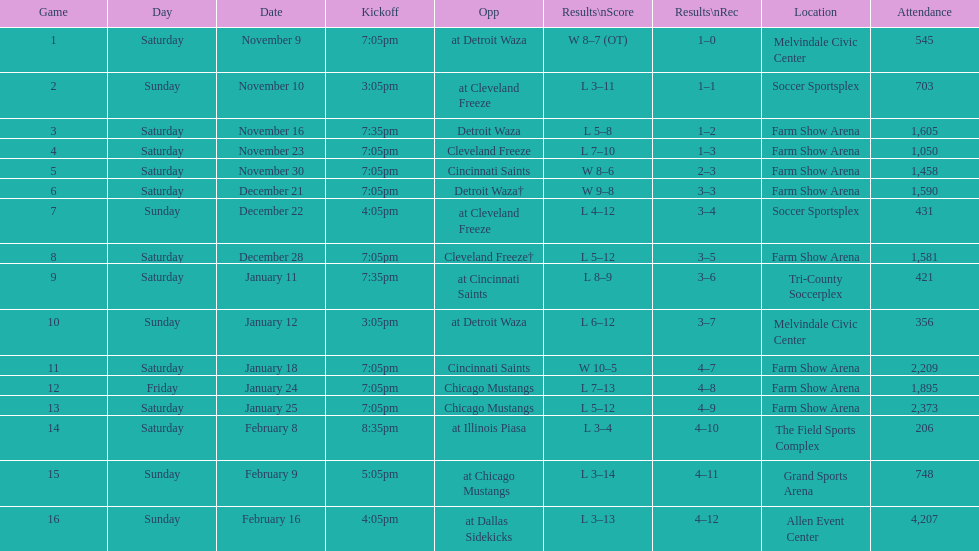How many games did the harrisburg heat lose to the cleveland freeze in total. 4. 